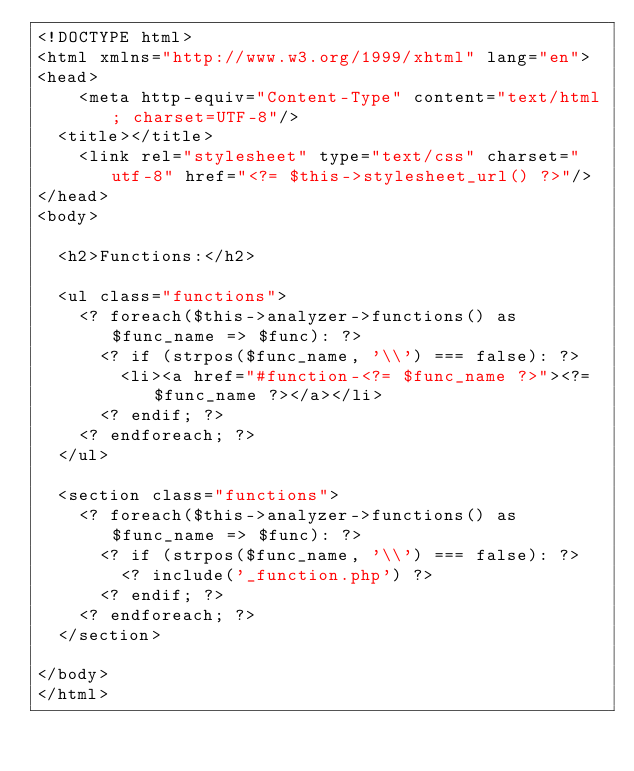<code> <loc_0><loc_0><loc_500><loc_500><_PHP_><!DOCTYPE html>
<html xmlns="http://www.w3.org/1999/xhtml" lang="en">
<head>
	<meta http-equiv="Content-Type" content="text/html; charset=UTF-8"/>
  <title></title>
	<link rel="stylesheet" type="text/css" charset="utf-8" href="<?= $this->stylesheet_url() ?>"/>
</head>
<body>
  
  <h2>Functions:</h2>
  
  <ul class="functions">
    <? foreach($this->analyzer->functions() as $func_name => $func): ?>
      <? if (strpos($func_name, '\\') === false): ?>
        <li><a href="#function-<?= $func_name ?>"><?= $func_name ?></a></li>
      <? endif; ?>
    <? endforeach; ?>
  </ul>
  
  <section class="functions">
    <? foreach($this->analyzer->functions() as $func_name => $func): ?>
      <? if (strpos($func_name, '\\') === false): ?>
        <? include('_function.php') ?>
      <? endif; ?>
    <? endforeach; ?>
  </section>

</body>
</html>
</code> 